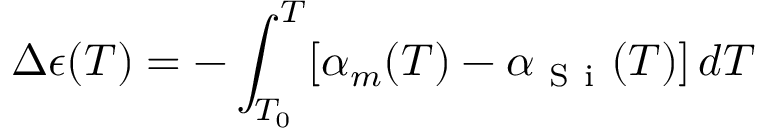Convert formula to latex. <formula><loc_0><loc_0><loc_500><loc_500>\Delta \epsilon ( T ) = - \int _ { T _ { 0 } } ^ { T } [ \alpha _ { m } ( T ) - \alpha _ { S i } ( T ) ] \, d T</formula> 